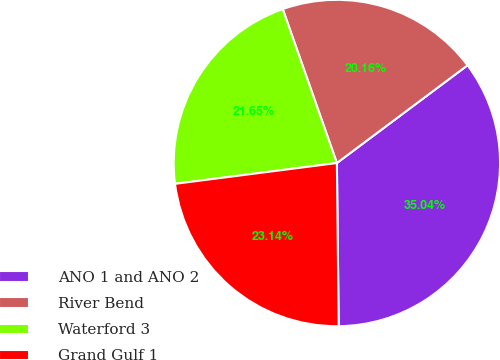Convert chart to OTSL. <chart><loc_0><loc_0><loc_500><loc_500><pie_chart><fcel>ANO 1 and ANO 2<fcel>River Bend<fcel>Waterford 3<fcel>Grand Gulf 1<nl><fcel>35.04%<fcel>20.16%<fcel>21.65%<fcel>23.14%<nl></chart> 